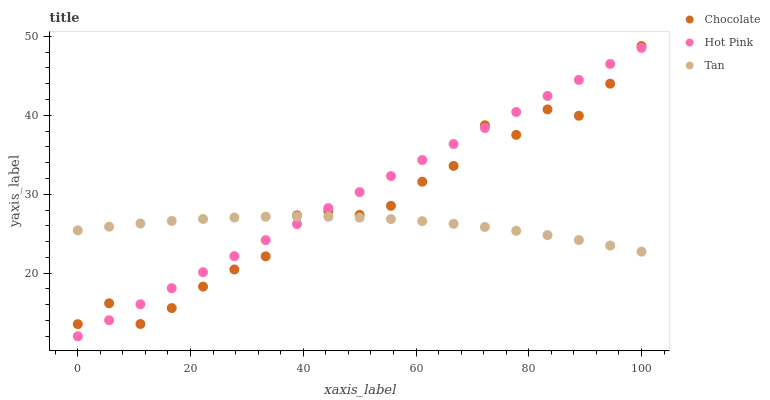Does Tan have the minimum area under the curve?
Answer yes or no. Yes. Does Hot Pink have the maximum area under the curve?
Answer yes or no. Yes. Does Chocolate have the minimum area under the curve?
Answer yes or no. No. Does Chocolate have the maximum area under the curve?
Answer yes or no. No. Is Hot Pink the smoothest?
Answer yes or no. Yes. Is Chocolate the roughest?
Answer yes or no. Yes. Is Chocolate the smoothest?
Answer yes or no. No. Is Hot Pink the roughest?
Answer yes or no. No. Does Hot Pink have the lowest value?
Answer yes or no. Yes. Does Chocolate have the lowest value?
Answer yes or no. No. Does Chocolate have the highest value?
Answer yes or no. Yes. Does Hot Pink have the highest value?
Answer yes or no. No. Does Tan intersect Hot Pink?
Answer yes or no. Yes. Is Tan less than Hot Pink?
Answer yes or no. No. Is Tan greater than Hot Pink?
Answer yes or no. No. 